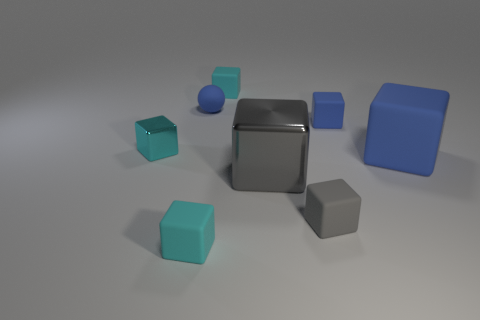There is a tiny rubber ball behind the small cyan shiny cube; does it have the same color as the large rubber cube?
Offer a very short reply. Yes. There is a small blue thing that is the same material as the small blue block; what is its shape?
Keep it short and to the point. Sphere. What is the color of the cube that is both on the left side of the small gray rubber object and in front of the large gray block?
Offer a terse response. Cyan. There is a metal thing on the right side of the tiny cyan rubber block that is in front of the big blue object; how big is it?
Your response must be concise. Large. Is there a small rubber ball that has the same color as the big matte thing?
Offer a very short reply. Yes. Are there the same number of large gray objects that are in front of the large metal cube and big blue rubber cubes?
Offer a very short reply. No. How many matte things are there?
Your response must be concise. 6. Is the color of the rubber ball behind the large metallic cube the same as the thing right of the small blue block?
Your response must be concise. Yes. Are there any objects that have the same material as the big gray cube?
Provide a succinct answer. Yes. Is the number of small blocks behind the tiny cyan metallic block the same as the number of blue rubber cubes on the left side of the small blue rubber ball?
Your answer should be very brief. No. 